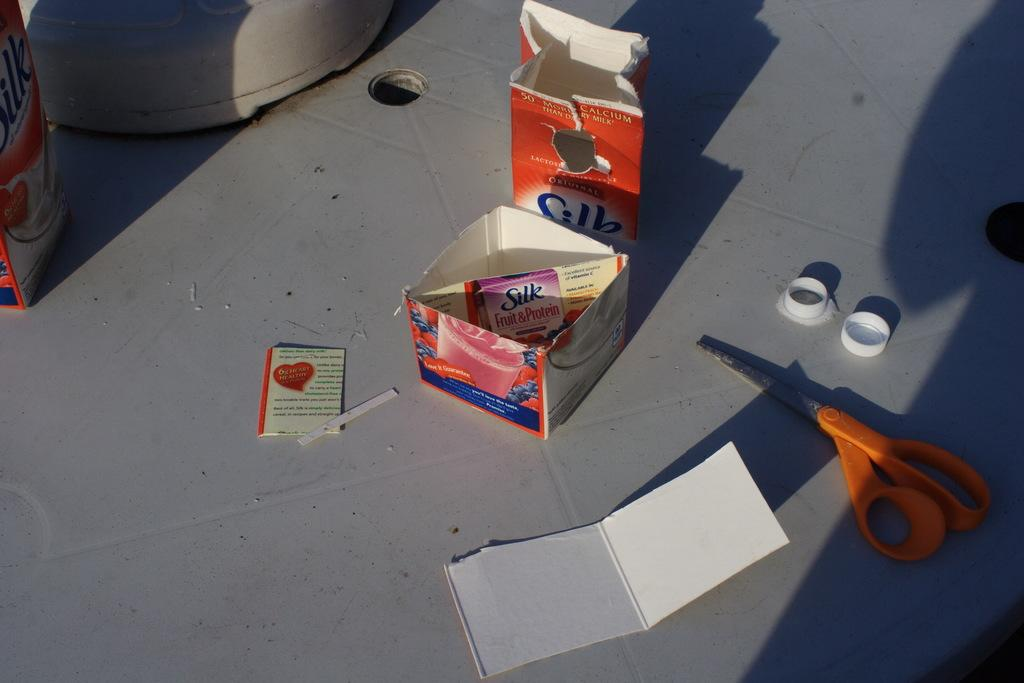<image>
Summarize the visual content of the image. Someone has cut up the Silk soy milk carton into a small box with diagonal divider in the middle. 